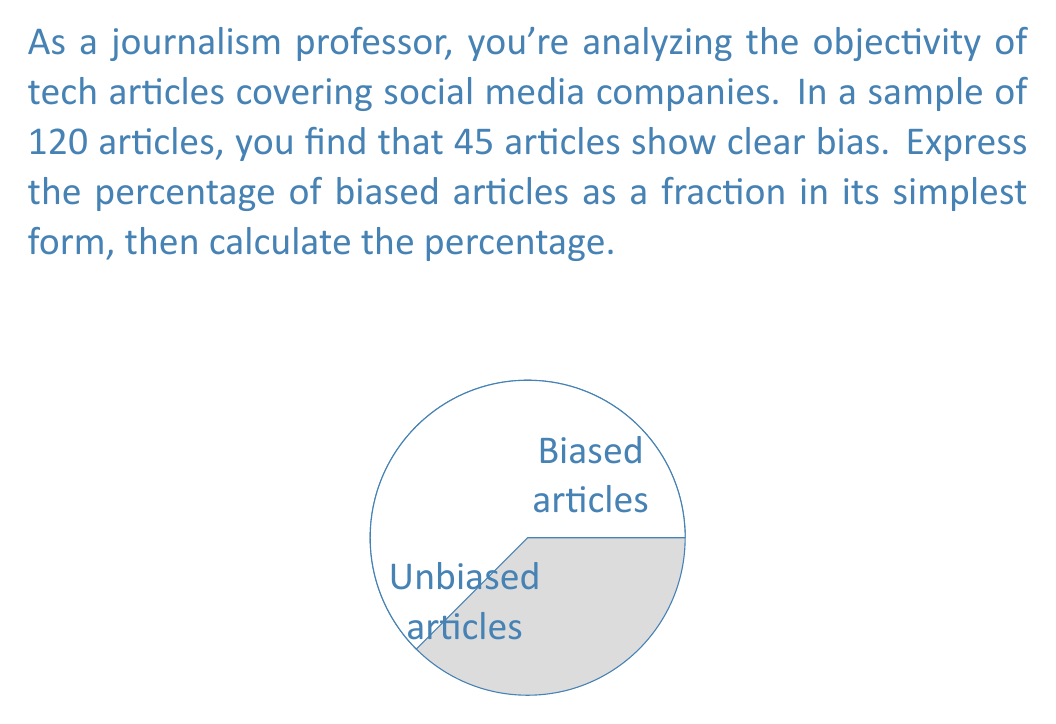Could you help me with this problem? 1) First, let's express the biased articles as a fraction of the total:
   Fraction of biased articles = $\frac{\text{Number of biased articles}}{\text{Total number of articles}} = \frac{45}{120}$

2) Simplify this fraction:
   $\frac{45}{120} = \frac{45 \div 15}{120 \div 15} = \frac{3}{8}$

3) To convert a fraction to a percentage, multiply by 100:
   $\frac{3}{8} \times 100 = 37.5\%$

4) Alternatively, we can calculate this directly:
   $\frac{45}{120} \times 100 = 0.375 \times 100 = 37.5\%$

Therefore, the percentage of biased articles is 37.5%.
Answer: $\frac{3}{8}$ or 37.5% 